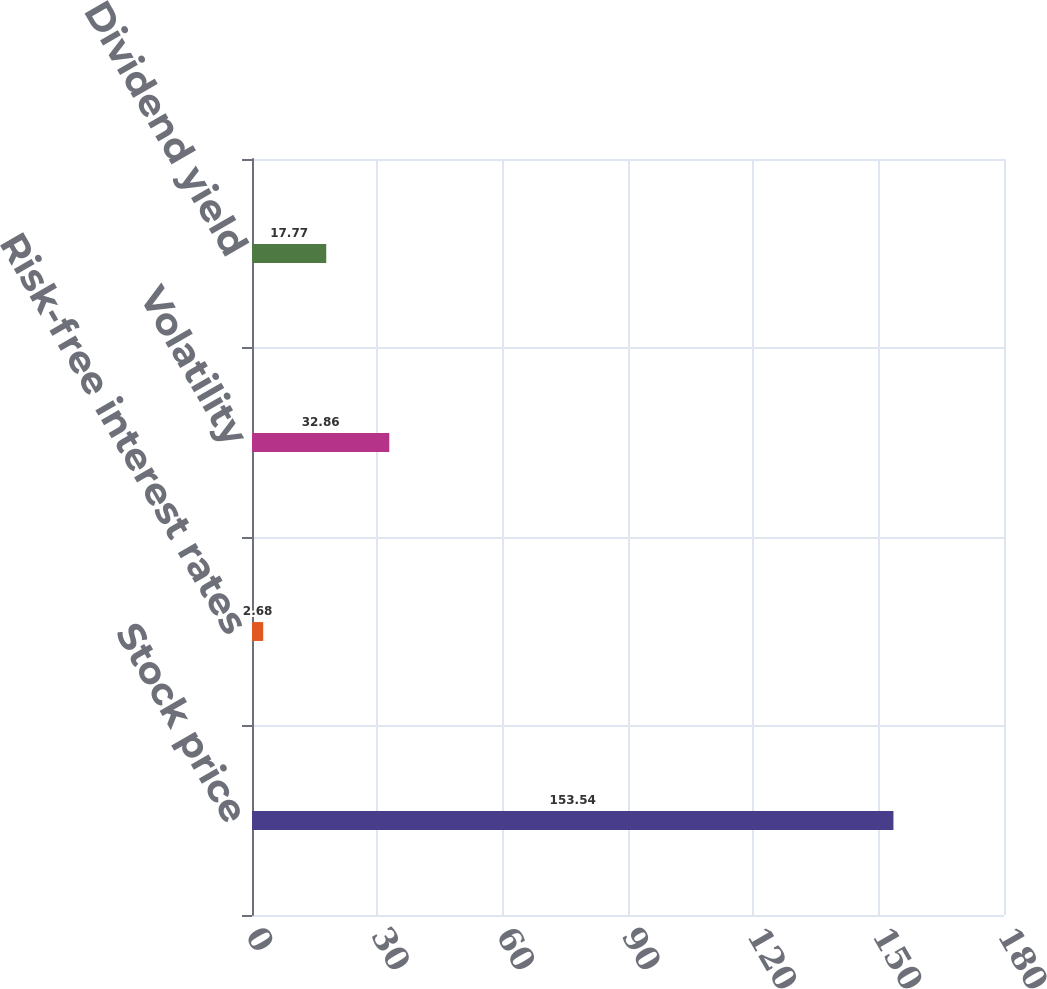Convert chart to OTSL. <chart><loc_0><loc_0><loc_500><loc_500><bar_chart><fcel>Stock price<fcel>Risk-free interest rates<fcel>Volatility<fcel>Dividend yield<nl><fcel>153.54<fcel>2.68<fcel>32.86<fcel>17.77<nl></chart> 